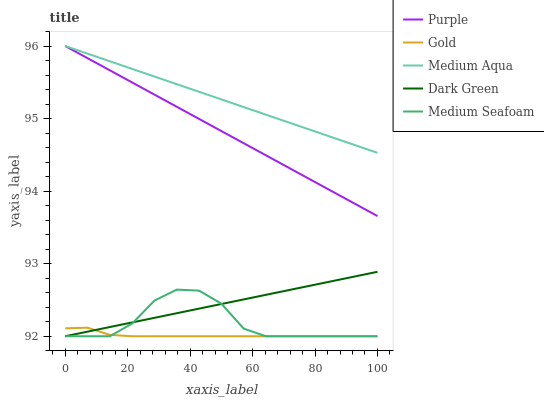Does Gold have the minimum area under the curve?
Answer yes or no. Yes. Does Medium Aqua have the maximum area under the curve?
Answer yes or no. Yes. Does Medium Seafoam have the minimum area under the curve?
Answer yes or no. No. Does Medium Seafoam have the maximum area under the curve?
Answer yes or no. No. Is Medium Aqua the smoothest?
Answer yes or no. Yes. Is Medium Seafoam the roughest?
Answer yes or no. Yes. Is Medium Seafoam the smoothest?
Answer yes or no. No. Is Medium Aqua the roughest?
Answer yes or no. No. Does Medium Aqua have the lowest value?
Answer yes or no. No. Does Medium Aqua have the highest value?
Answer yes or no. Yes. Does Medium Seafoam have the highest value?
Answer yes or no. No. Is Dark Green less than Medium Aqua?
Answer yes or no. Yes. Is Purple greater than Medium Seafoam?
Answer yes or no. Yes. Does Dark Green intersect Medium Aqua?
Answer yes or no. No. 